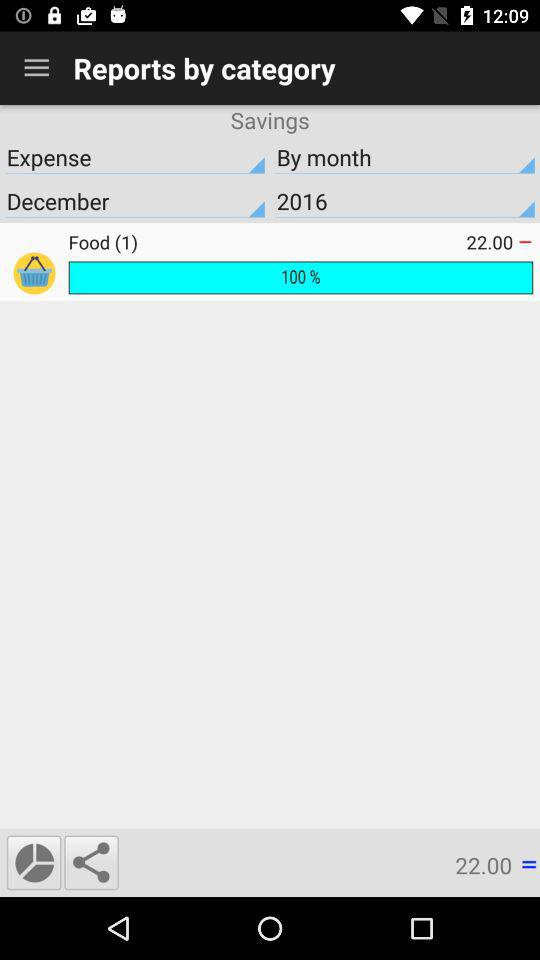What is the selected month? The selected month is December. 